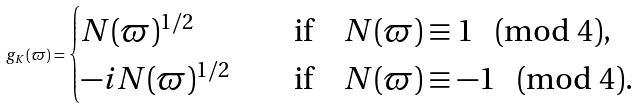Convert formula to latex. <formula><loc_0><loc_0><loc_500><loc_500>g _ { K } ( \varpi ) = \begin{cases} N ( \varpi ) ^ { 1 / 2 } \quad & \text {if} \quad N ( \varpi ) \equiv 1 \pmod { 4 } , \\ - i N ( \varpi ) ^ { 1 / 2 } \quad & \text {if} \quad N ( \varpi ) \equiv - 1 \pmod { 4 } . \end{cases}</formula> 